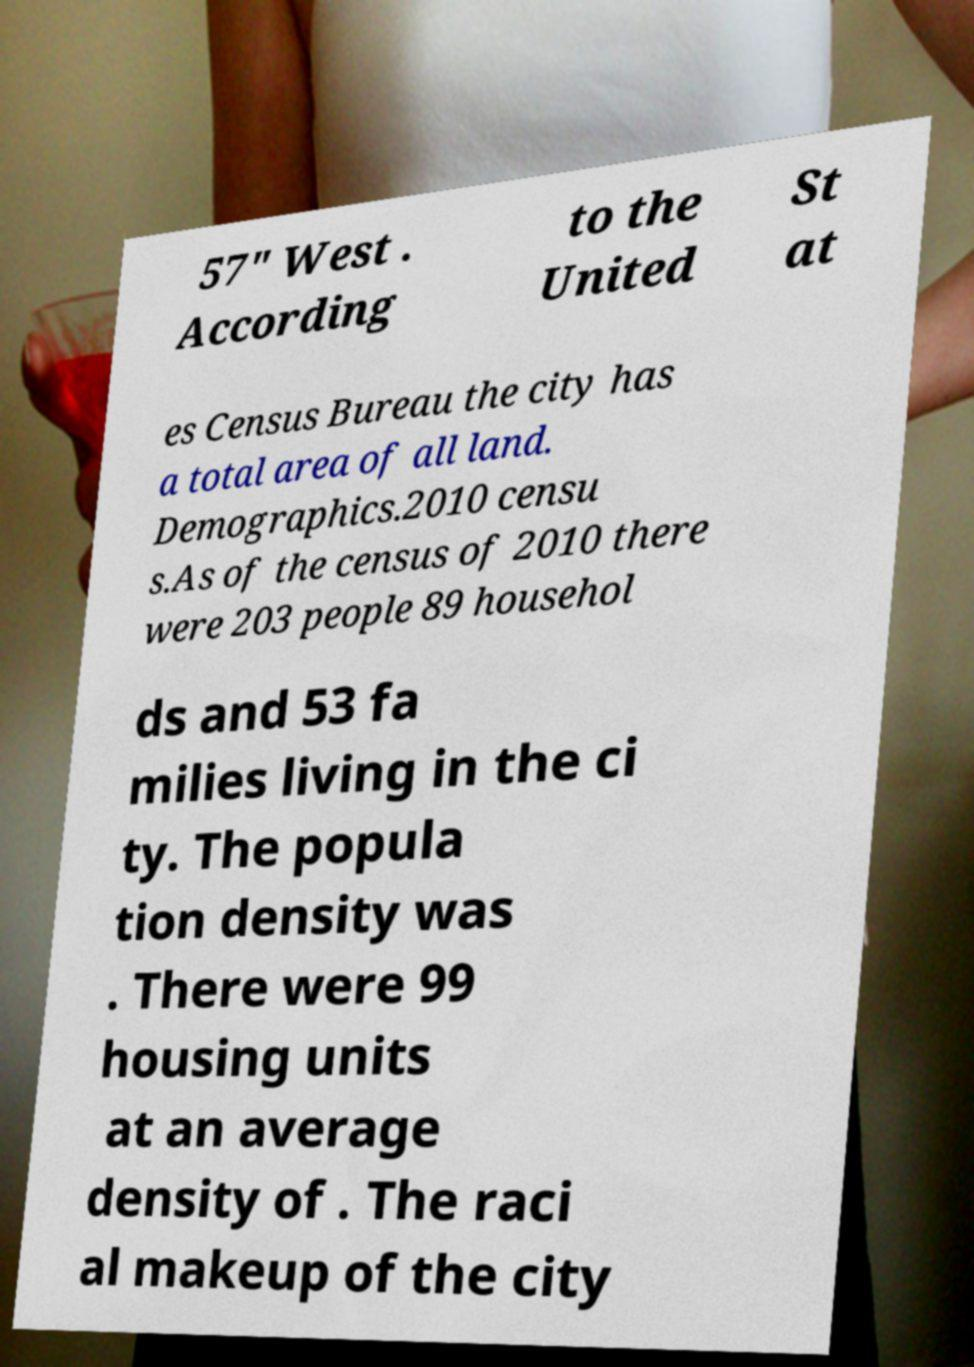Please read and relay the text visible in this image. What does it say? 57" West . According to the United St at es Census Bureau the city has a total area of all land. Demographics.2010 censu s.As of the census of 2010 there were 203 people 89 househol ds and 53 fa milies living in the ci ty. The popula tion density was . There were 99 housing units at an average density of . The raci al makeup of the city 